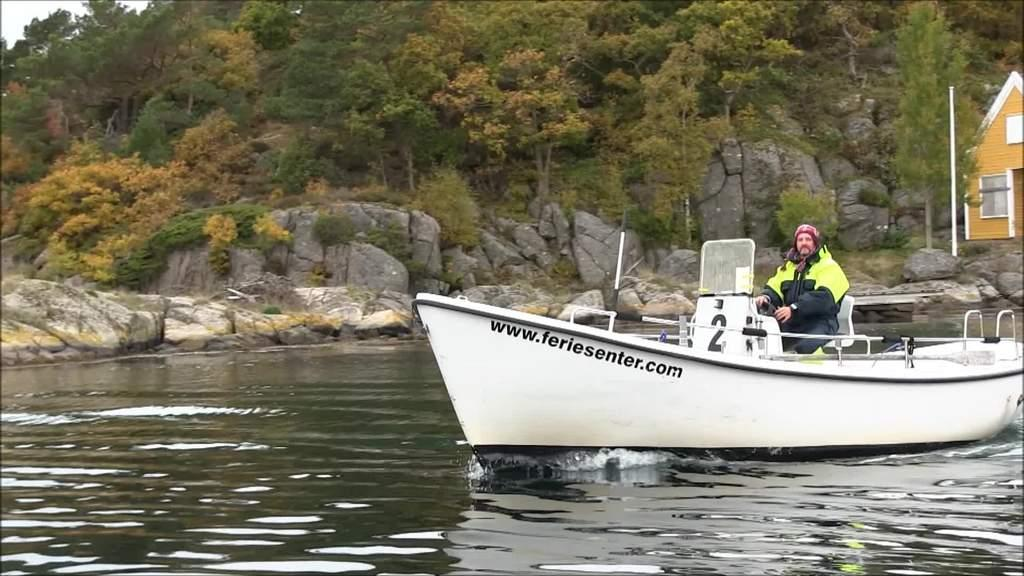What is the main subject of the image? There is a person in the image. What type of clothing is the person wearing? The person is wearing a high-wiz jacket. What activity is the person engaged in? The person is riding a motor boat. Where is the motor boat located? The motor boat is on the water. What can be seen in the background of the image? There are trees and rocks in the background of the image. What type of yam is growing on the rocks in the image? There is no yam present in the image; it features a person riding a motor boat on the water with trees and rocks in the background. 